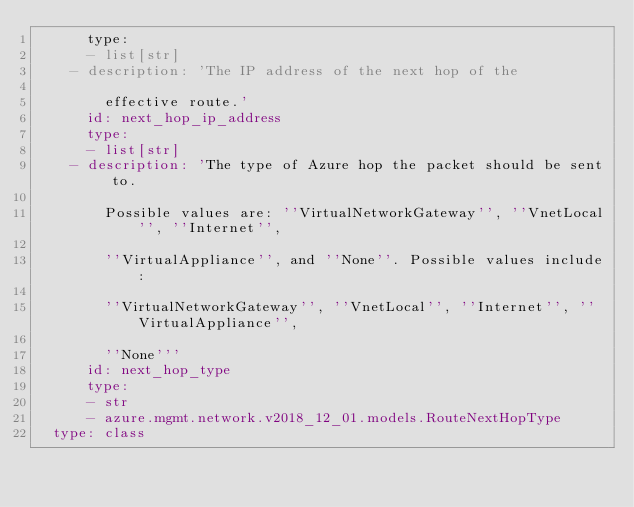<code> <loc_0><loc_0><loc_500><loc_500><_YAML_>      type:
      - list[str]
    - description: 'The IP address of the next hop of the

        effective route.'
      id: next_hop_ip_address
      type:
      - list[str]
    - description: 'The type of Azure hop the packet should be sent to.

        Possible values are: ''VirtualNetworkGateway'', ''VnetLocal'', ''Internet'',

        ''VirtualAppliance'', and ''None''. Possible values include:

        ''VirtualNetworkGateway'', ''VnetLocal'', ''Internet'', ''VirtualAppliance'',

        ''None'''
      id: next_hop_type
      type:
      - str
      - azure.mgmt.network.v2018_12_01.models.RouteNextHopType
  type: class</code> 